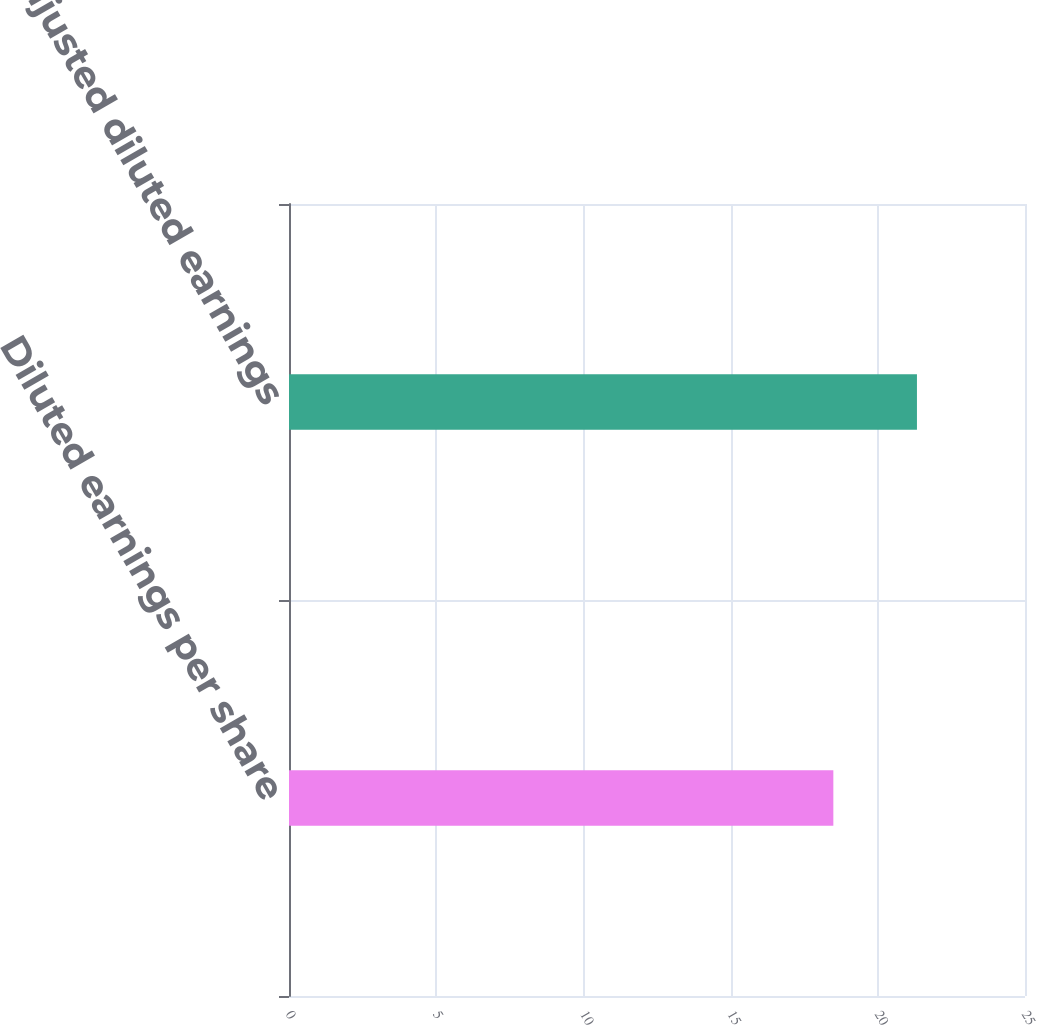Convert chart to OTSL. <chart><loc_0><loc_0><loc_500><loc_500><bar_chart><fcel>Diluted earnings per share<fcel>MTM-adjusted diluted earnings<nl><fcel>18.49<fcel>21.33<nl></chart> 